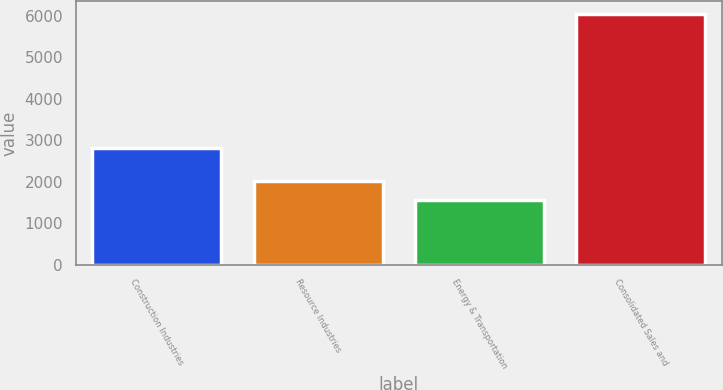Convert chart. <chart><loc_0><loc_0><loc_500><loc_500><bar_chart><fcel>Construction Industries<fcel>Resource Industries<fcel>Energy & Transportation<fcel>Consolidated Sales and<nl><fcel>2810<fcel>2005.9<fcel>1556<fcel>6055<nl></chart> 